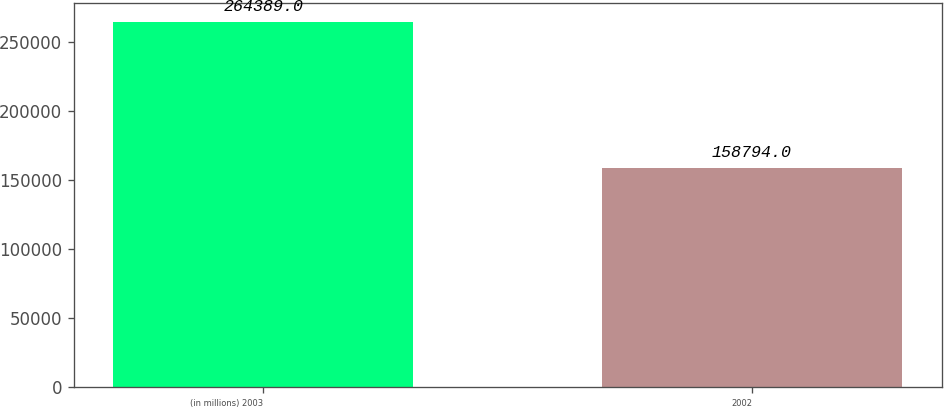Convert chart. <chart><loc_0><loc_0><loc_500><loc_500><bar_chart><fcel>(in millions) 2003<fcel>2002<nl><fcel>264389<fcel>158794<nl></chart> 